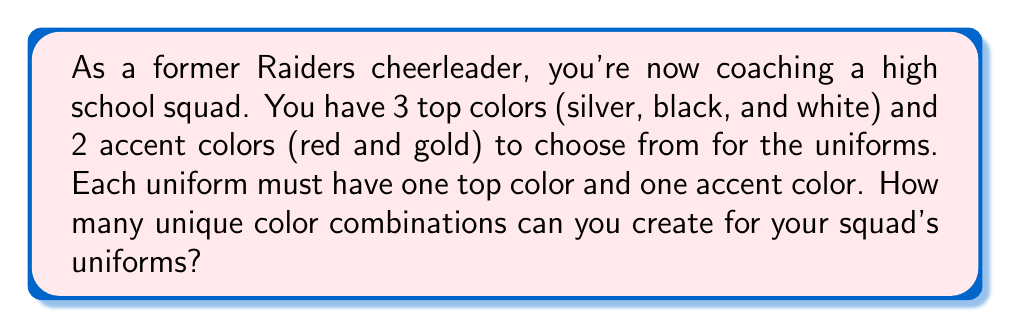Provide a solution to this math problem. Let's approach this step-by-step:

1) We need to choose one top color and one accent color for each uniform.

2) For the top color, we have 3 choices: silver, black, and white.

3) For the accent color, we have 2 choices: red and gold.

4) To find the total number of unique combinations, we use the multiplication principle of counting. This principle states that if we have $m$ ways of doing one thing and $n$ ways of doing another thing, then there are $m \times n$ ways of doing both things.

5) In this case:
   - We have 3 ways to choose the top color
   - We have 2 ways to choose the accent color

6) Therefore, the total number of unique combinations is:

   $$ 3 \times 2 = 6 $$

Thus, there are 6 possible unique color combinations for the cheerleading uniforms.
Answer: 6 